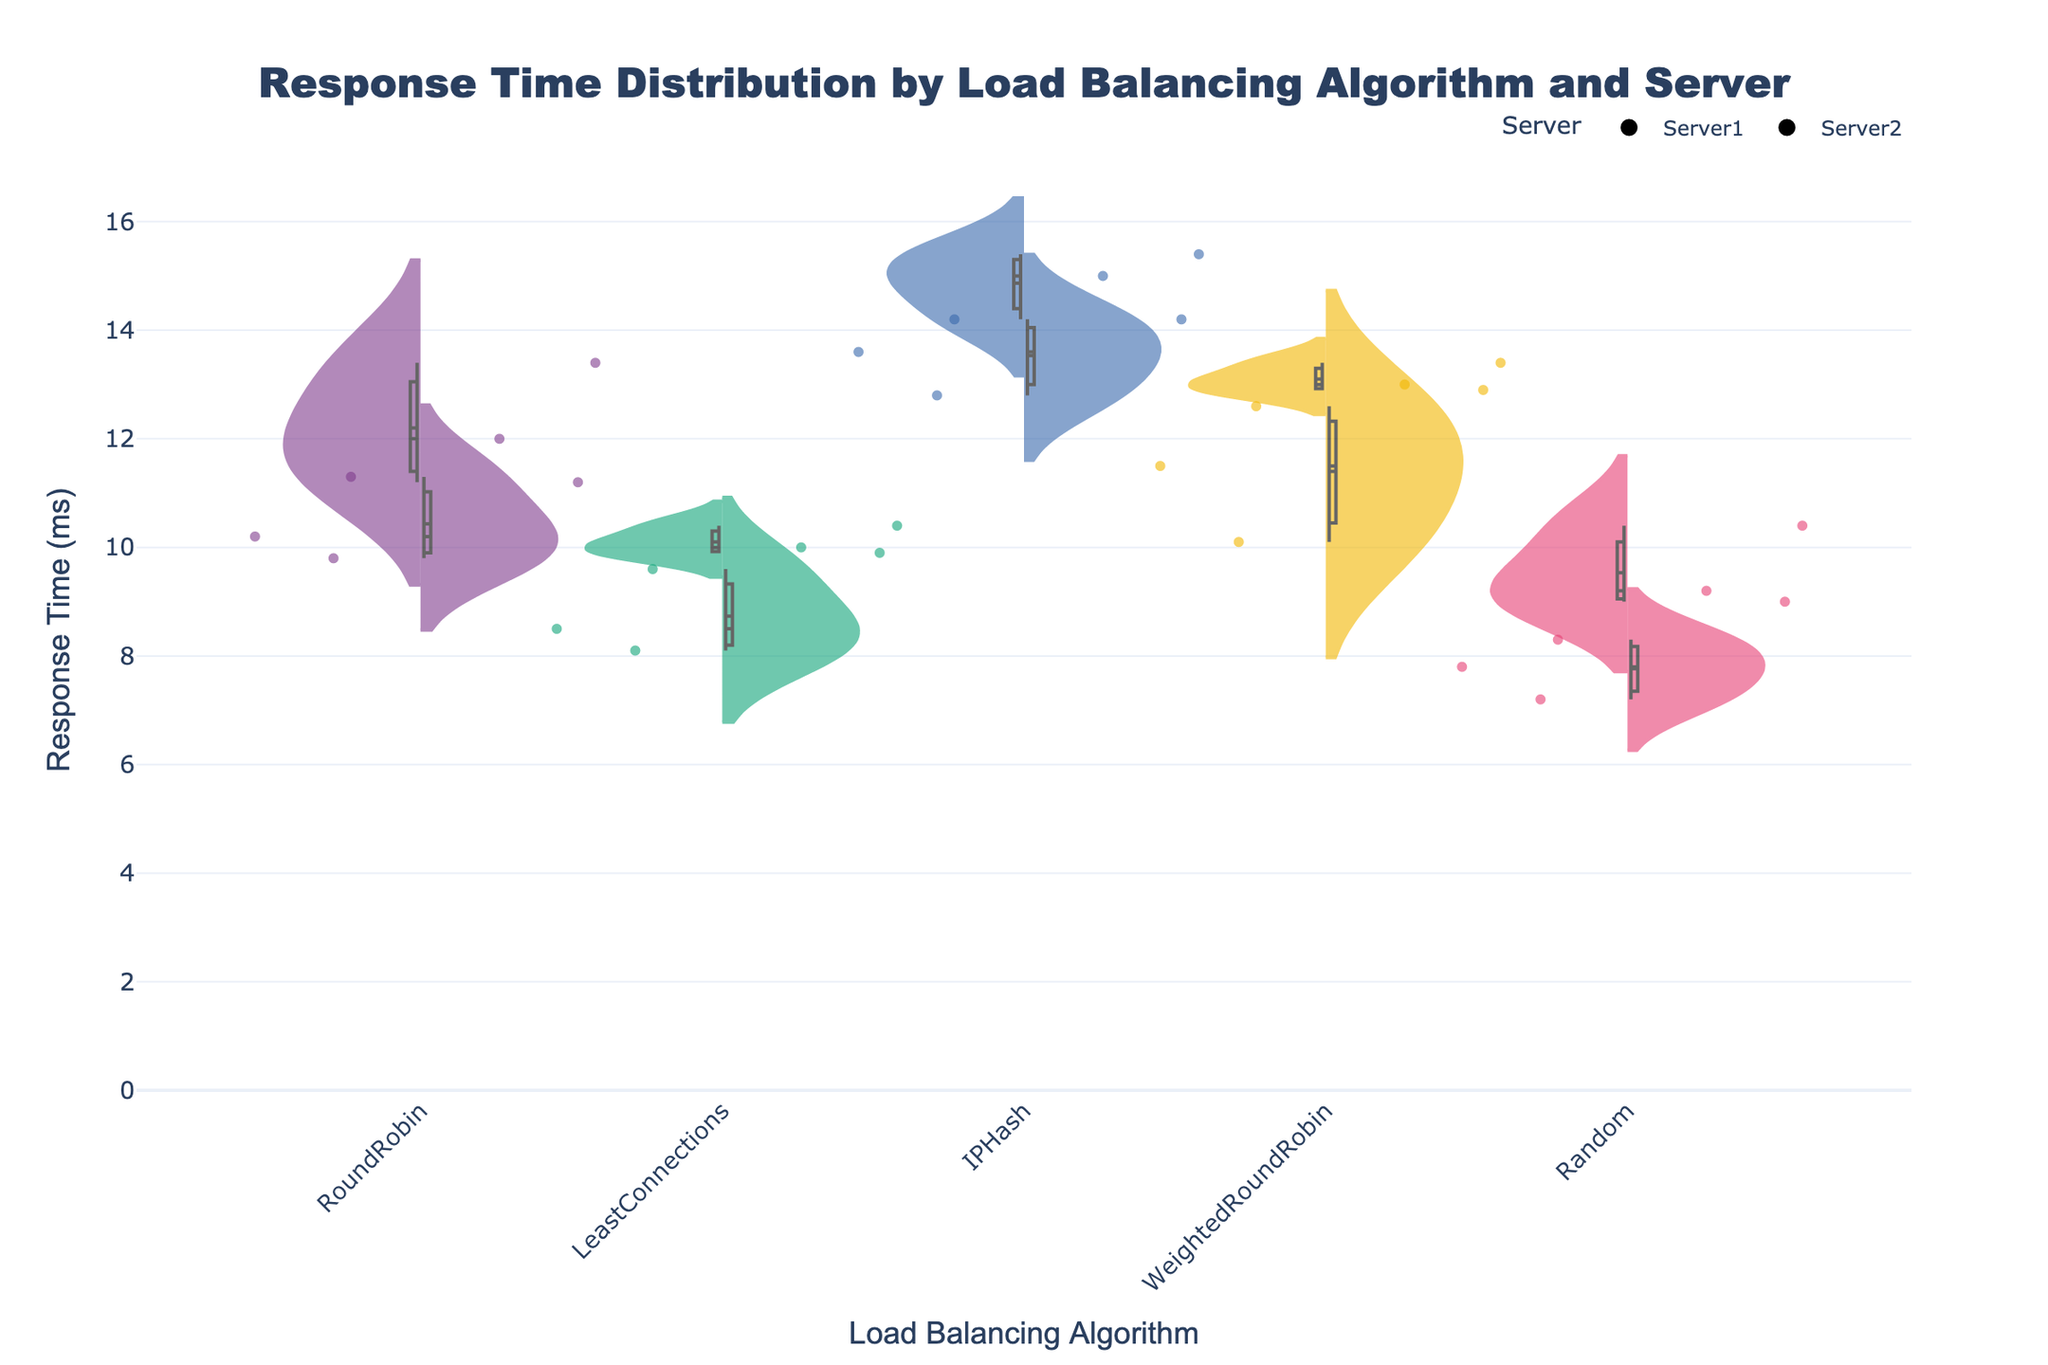What's the title of the figure? The title of the figure is generally displayed at the top of the plot for easy identification. It summarizes what the visualization is about. The title appears clearly at the top.
Answer: Response Time Distribution by Load Balancing Algorithm and Server Which algorithm shows the highest response time on Server 1? By examining the peak values on the y-axis for each split violin plot associated with Server 1 across different algorithms, we can identify the algorithm with the highest point. IPHash shows the tallest section for Server 1.
Answer: IPHash What is the range of response times for the LeastConnections algorithm on Server 2? The range can be identified by locating the minimum and maximum values within the split violin plot for the LeastConnections algorithm on Server 2. The lower boundary is around 9.9 ms, and the upper boundary is around 10.4 ms.
Answer: 9.9 ms to 10.4 ms Which server generally exhibits lower response times for the Random algorithm? A comparison between the two halves of the split violin plot for the Random algorithm will show which side has lower values on the y-axis. Server 1 has visibly lower points than Server 2.
Answer: Server 1 Between RoundRobin and WeightedRoundRobin, which algorithm has a more varied response time distribution on Server 2? To gauge variability, we look at the spread or width of the violin plots on Server 2 for both algorithms. RoundRobin has a wider violin plot on Server 2, indicating more varied response times.
Answer: RoundRobin What's the median response time for IPHash on Server 2? The median can be found by identifying the central lines within the violin plot for the IPHash algorithm on Server 2. This line represents the median of the distribution. Observing this, the median is around 15.0 ms.
Answer: 15.0 ms How does the average response time for RoundRobin on Server 1 compare to the average response time for Random on Server 2? We compare the mean lines (generally a small horizontal mark) within the violin plots for the described categories. RoundRobin on Server 1 has a higher average line around 10.4 ms compared to Random on Server 2, which is about 8.4 ms.
Answer: RoundRobin is higher Which algorithm shows the least response time variation across both servers? Least response time variation can be identified by looking at the narrowest violin plots across both Server 1 and Server 2. LeastConnections shows a very tight distribution on both servers.
Answer: LeastConnections 